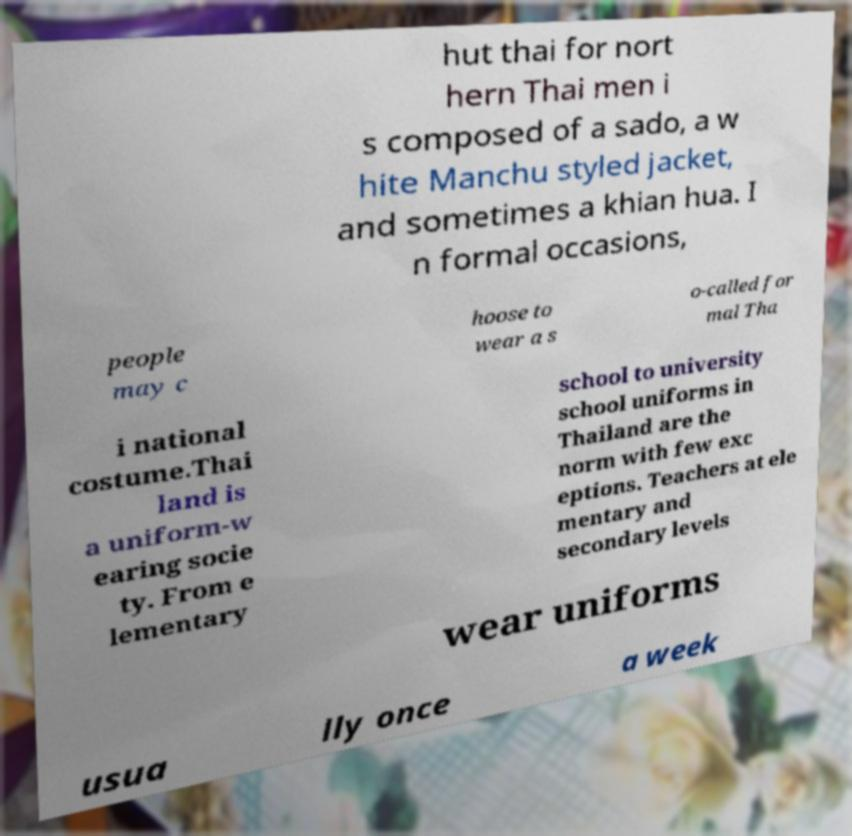There's text embedded in this image that I need extracted. Can you transcribe it verbatim? hut thai for nort hern Thai men i s composed of a sado, a w hite Manchu styled jacket, and sometimes a khian hua. I n formal occasions, people may c hoose to wear a s o-called for mal Tha i national costume.Thai land is a uniform-w earing socie ty. From e lementary school to university school uniforms in Thailand are the norm with few exc eptions. Teachers at ele mentary and secondary levels wear uniforms usua lly once a week 